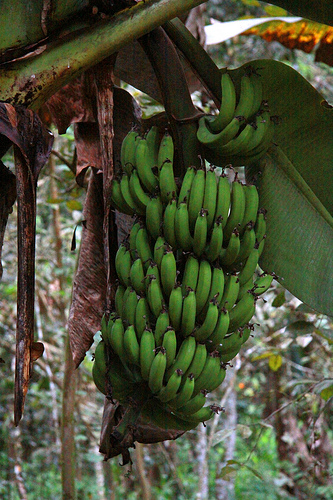Please provide a short description for this region: [0.44, 0.07, 0.58, 0.34]. This region captures a thick, dark green stem leading to a bunch of bananas. 